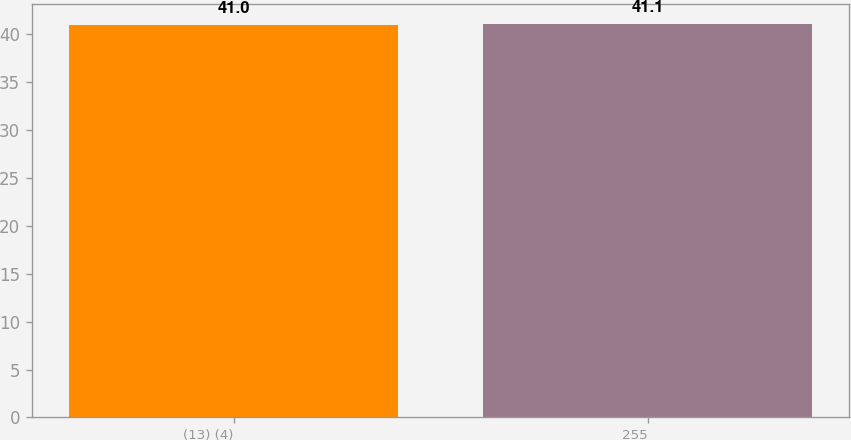Convert chart. <chart><loc_0><loc_0><loc_500><loc_500><bar_chart><fcel>(13) (4)<fcel>255<nl><fcel>41<fcel>41.1<nl></chart> 